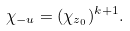<formula> <loc_0><loc_0><loc_500><loc_500>\chi _ { - u } = ( \chi _ { z _ { 0 } } ) ^ { k + 1 } .</formula> 